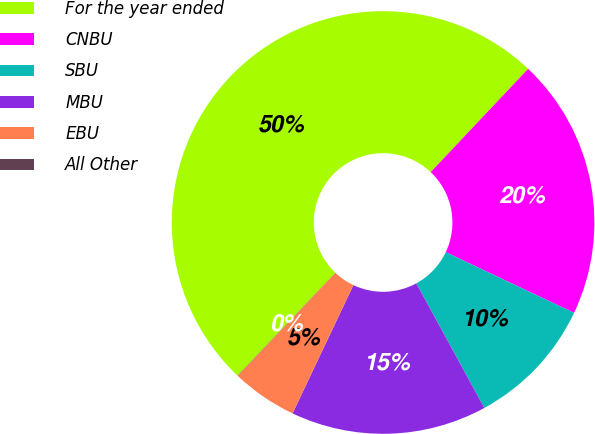<chart> <loc_0><loc_0><loc_500><loc_500><pie_chart><fcel>For the year ended<fcel>CNBU<fcel>SBU<fcel>MBU<fcel>EBU<fcel>All Other<nl><fcel>49.95%<fcel>20.0%<fcel>10.01%<fcel>15.0%<fcel>5.02%<fcel>0.02%<nl></chart> 